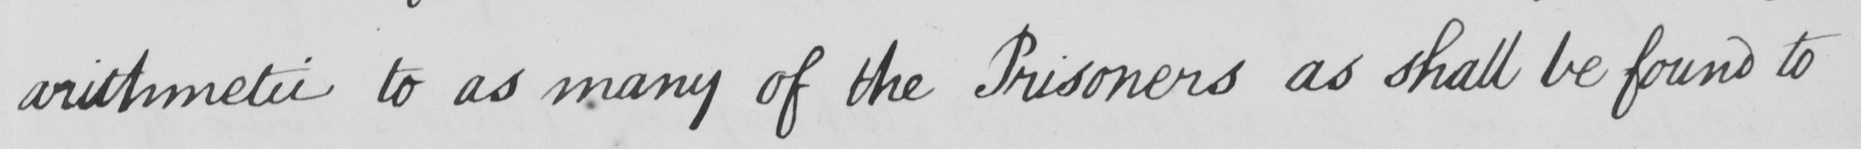Please provide the text content of this handwritten line. arithmetic to as many of the Prisoners as shall be found to 